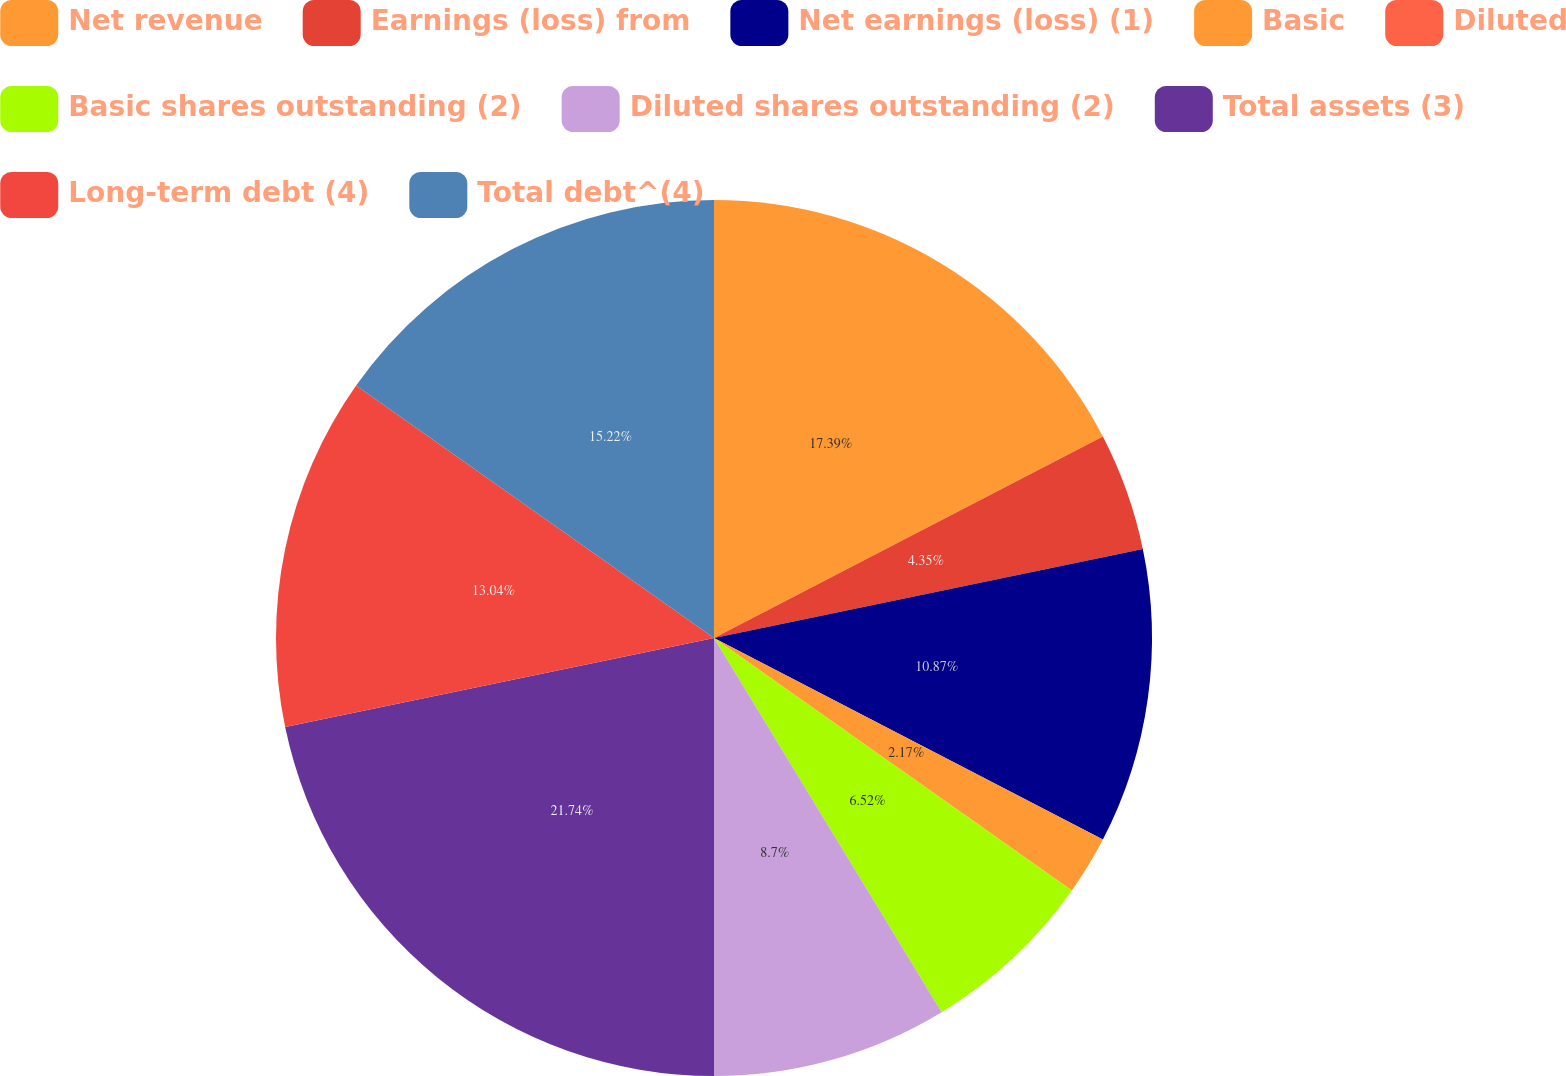Convert chart. <chart><loc_0><loc_0><loc_500><loc_500><pie_chart><fcel>Net revenue<fcel>Earnings (loss) from<fcel>Net earnings (loss) (1)<fcel>Basic<fcel>Diluted<fcel>Basic shares outstanding (2)<fcel>Diluted shares outstanding (2)<fcel>Total assets (3)<fcel>Long-term debt (4)<fcel>Total debt^(4)<nl><fcel>17.39%<fcel>4.35%<fcel>10.87%<fcel>2.17%<fcel>0.0%<fcel>6.52%<fcel>8.7%<fcel>21.74%<fcel>13.04%<fcel>15.22%<nl></chart> 